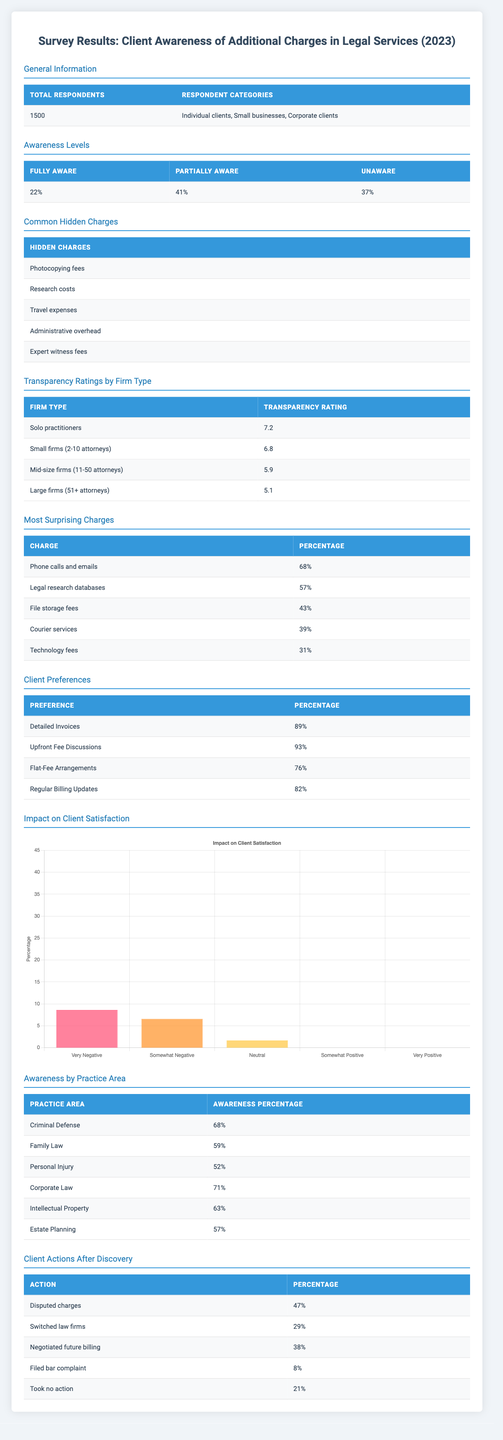What percentage of respondents are unaware of additional charges in legal services? The table indicates that 37% of respondents fall under the "unaware" category in the awareness levels section.
Answer: 37% What is the most surprising charge for clients, according to the survey? The most surprising charge is "Phone calls and emails," which 68% of respondents found surprising.
Answer: Phone calls and emails What is the average transparency rating for small firms and large firms? The transparency rating for small firms is 6.8, and for large firms, it is 5.1. The average is (6.8 + 5.1) / 2 = 5.95.
Answer: 5.95 What action did the least percentage of clients take after discovering additional charges? The least percentage of clients who took action was "Filed bar complaint" at 8%, as shown in the client actions section.
Answer: Filed bar complaint How many respondents are either fully aware or partially aware of their potential charges? The fully aware respondents are 22%, and the partially aware ones are 41%. The sum is 22 + 41 = 63%.
Answer: 63% Do small businesses have a higher awareness of hidden charges in legal services than individuals? The data does not directly provide this comparison as the awareness by category does not specify individual clients versus small businesses.
Answer: No What percentage of clients prefer detailed invoices? According to the client preferences, 89% of respondents prefer detailed invoices.
Answer: 89% Which legal practice area has the highest awareness of additional charges? The awareness by practice area shows that "Corporate Law" has the highest percentage at 71%.
Answer: Corporate Law How does the transparency rating of mid-size firms compare to that of solo practitioners? The mid-size firms have a transparency rating of 5.9, while solo practitioners have a rating of 7.2. Since 7.2 > 5.9, solo practitioners have a higher rating.
Answer: Solo practitioners have a higher rating What is the combined percentage of clients who took no action or filed a bar complaint? The percentage for "Took no action" is 21% and for "Filed bar complaint" is 8%. The sum is 21 + 8 = 29%.
Answer: 29% 